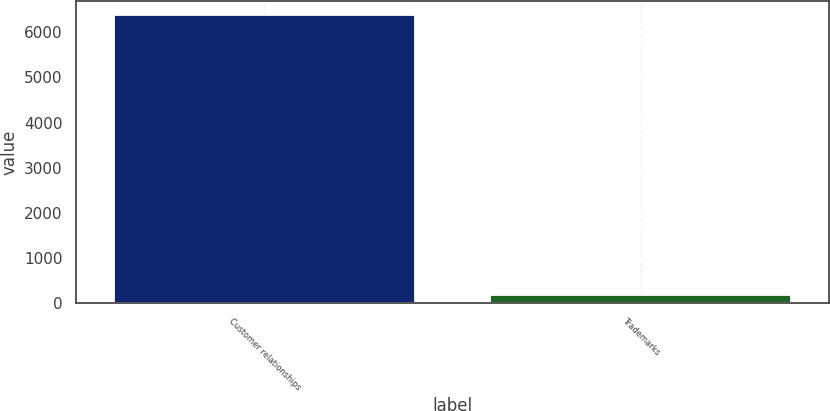Convert chart to OTSL. <chart><loc_0><loc_0><loc_500><loc_500><bar_chart><fcel>Customer relationships<fcel>Trademarks<nl><fcel>6367<fcel>180<nl></chart> 